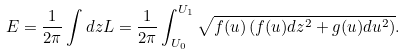<formula> <loc_0><loc_0><loc_500><loc_500>E = \frac { 1 } { 2 \pi } \int d z L = \frac { 1 } { 2 \pi } \int ^ { U _ { 1 } } _ { U _ { 0 } } \sqrt { f ( u ) \left ( f ( u ) d z ^ { 2 } + g ( u ) d u ^ { 2 } \right ) } .</formula> 